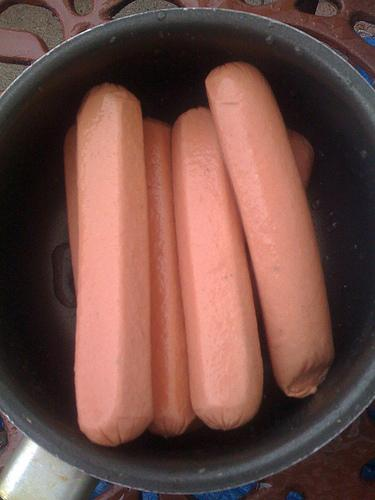List the central elements and colors observed within the image. Five hotdogs, black pan, silver handle. Create a brief commentary on what is happening in the image. A cluster of five hotdogs are placed in a pan. Write a concise overview of the image's features and the activity displayed. The image shows five hotdogs placed in a black pan with a silver handle. Explain the key details associated with the hotdogs in the image. There are five hotdogs in a black pan with a silver handle. Write a short description of the main event taking place in the image. The image features five hotdogs placed in a black pan. Describe the main objects and activities displayed in the image. Five hotdogs placed in a pan with a silver handle. Provide a succinct description of the primary focus in the image. A pan containing five hotdogs. Briefly mention the main elements present in the image. Pan, five hotdogs, silver handle. Describe the cooking scene presented in the image. A group of five hotdogs placed in a black pan. Write a sentence narrating the core happening in the image. Five hotdogs are placed in a black pan. 